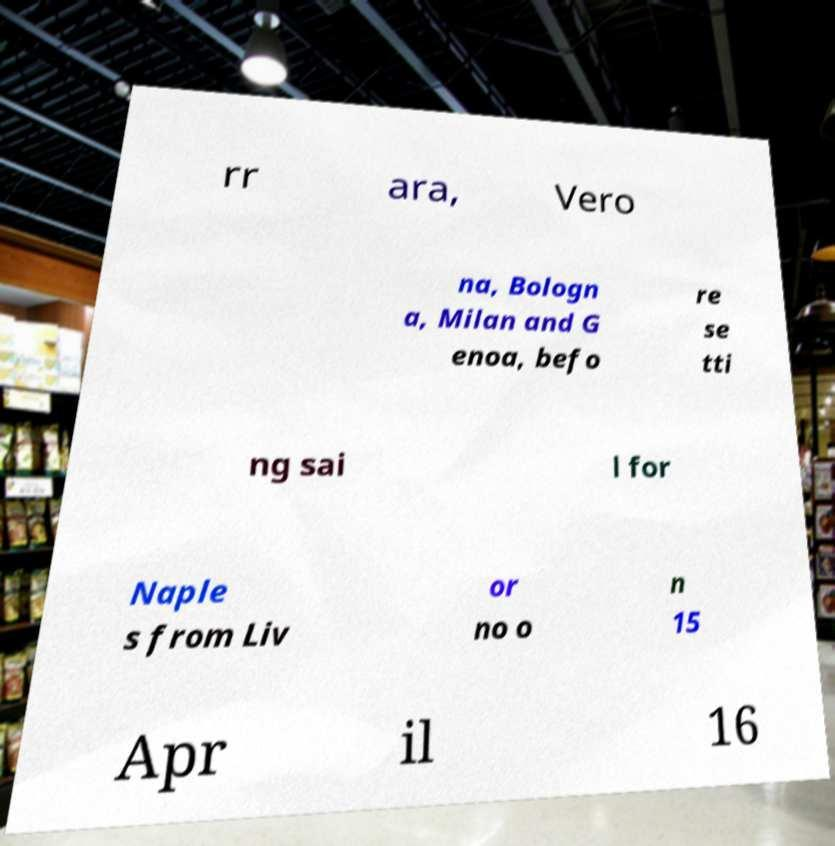There's text embedded in this image that I need extracted. Can you transcribe it verbatim? rr ara, Vero na, Bologn a, Milan and G enoa, befo re se tti ng sai l for Naple s from Liv or no o n 15 Apr il 16 